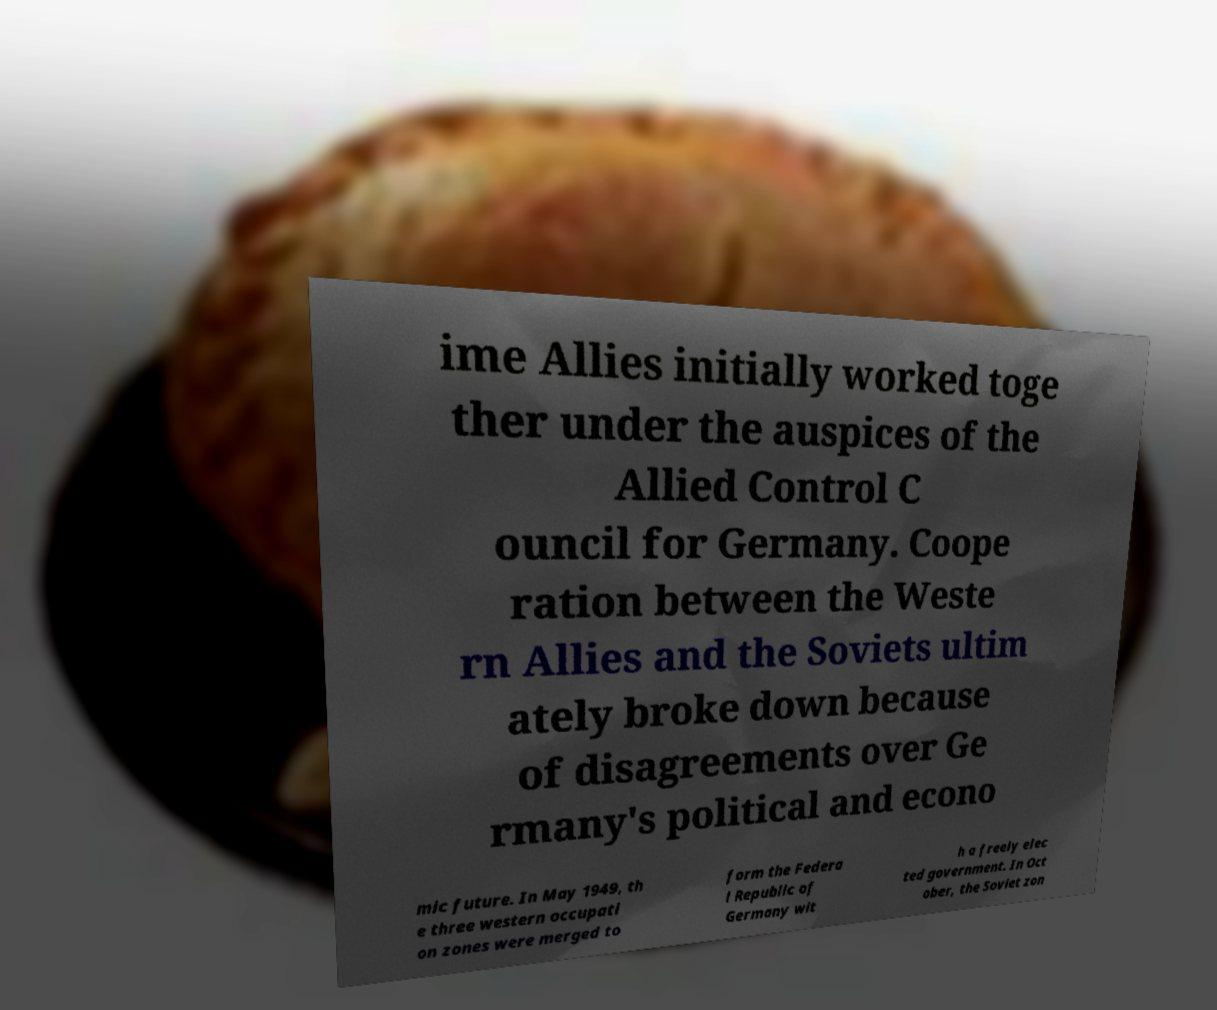Could you extract and type out the text from this image? ime Allies initially worked toge ther under the auspices of the Allied Control C ouncil for Germany. Coope ration between the Weste rn Allies and the Soviets ultim ately broke down because of disagreements over Ge rmany's political and econo mic future. In May 1949, th e three western occupati on zones were merged to form the Federa l Republic of Germany wit h a freely elec ted government. In Oct ober, the Soviet zon 